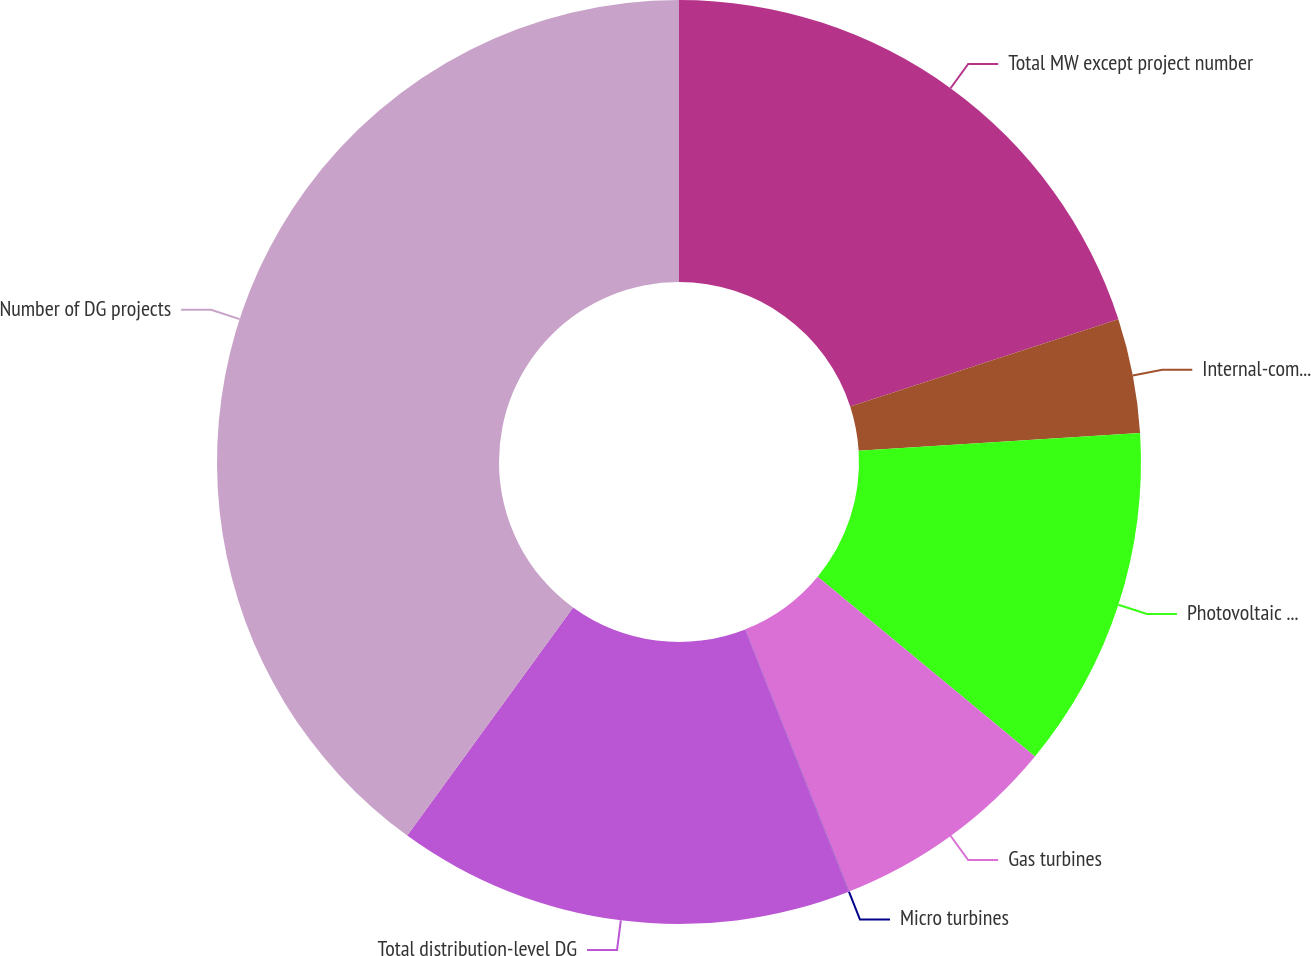Convert chart to OTSL. <chart><loc_0><loc_0><loc_500><loc_500><pie_chart><fcel>Total MW except project number<fcel>Internal-combustion engines<fcel>Photovoltaic solar<fcel>Gas turbines<fcel>Micro turbines<fcel>Total distribution-level DG<fcel>Number of DG projects<nl><fcel>20.0%<fcel>4.0%<fcel>12.0%<fcel>8.0%<fcel>0.01%<fcel>16.0%<fcel>39.99%<nl></chart> 